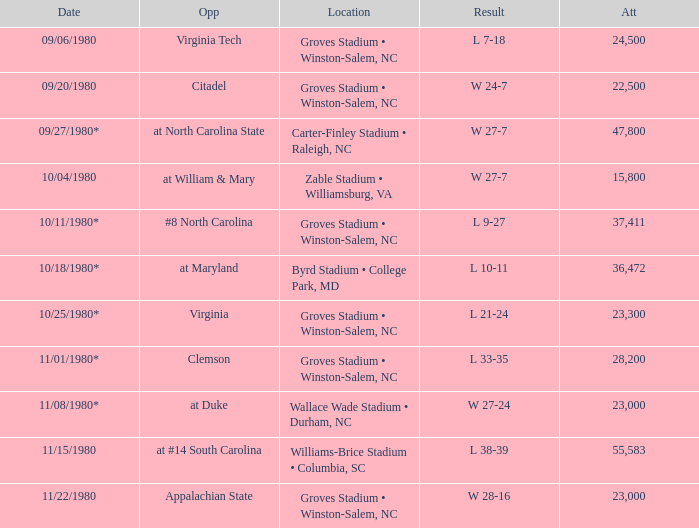How many people attended when Wake Forest played Virginia Tech? 24500.0. 